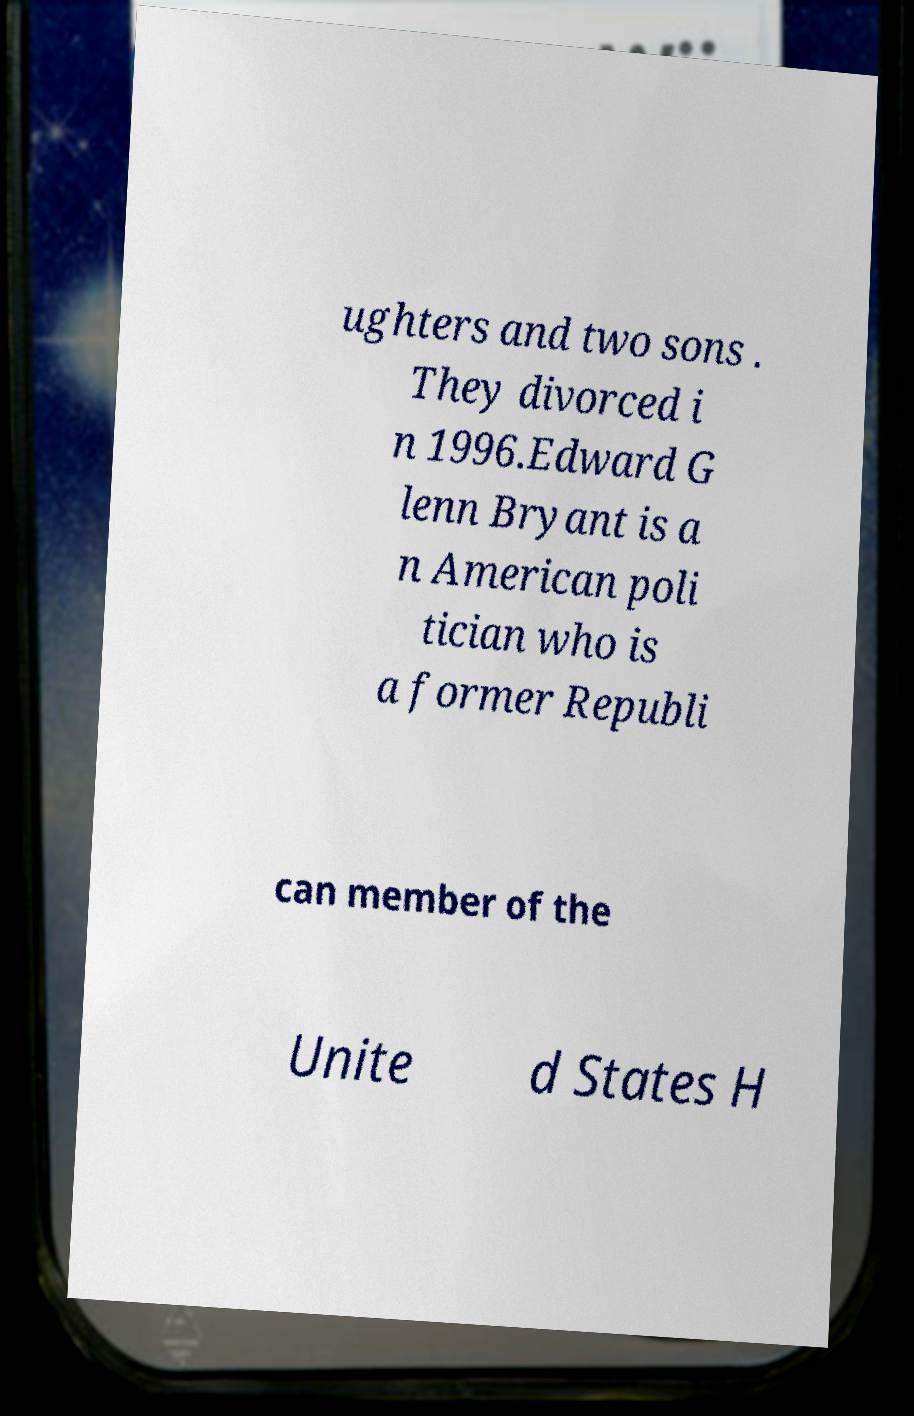Can you read and provide the text displayed in the image?This photo seems to have some interesting text. Can you extract and type it out for me? ughters and two sons . They divorced i n 1996.Edward G lenn Bryant is a n American poli tician who is a former Republi can member of the Unite d States H 